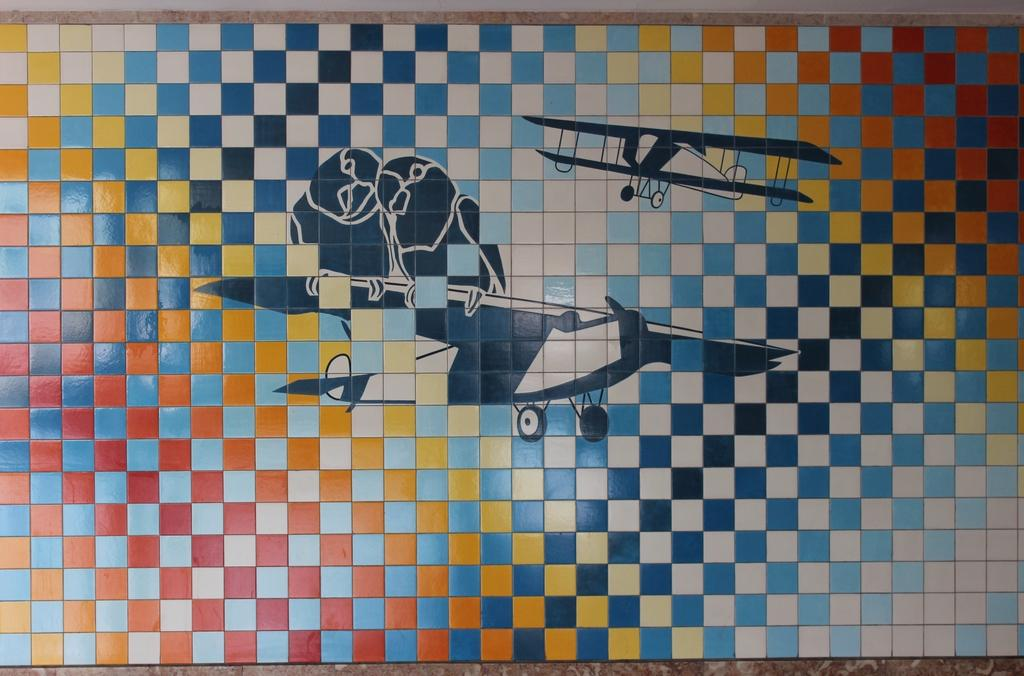What is the main object in the center of the image? There is a puzzle board in the center of the image. What can be seen in the background of the image? There is a floor visible in the background of the image. Reasoning: Let' Let's think step by step in order to produce the conversation. We start by identifying the main object in the image, which is the puzzle board. Then, we describe the background of the image, which is the floor. We avoid making any assumptions about the image and only focus on the facts provided. Absurd Question/Answer: How many bubbles are floating around the puzzle board in the image? There are no bubbles present in the image. 